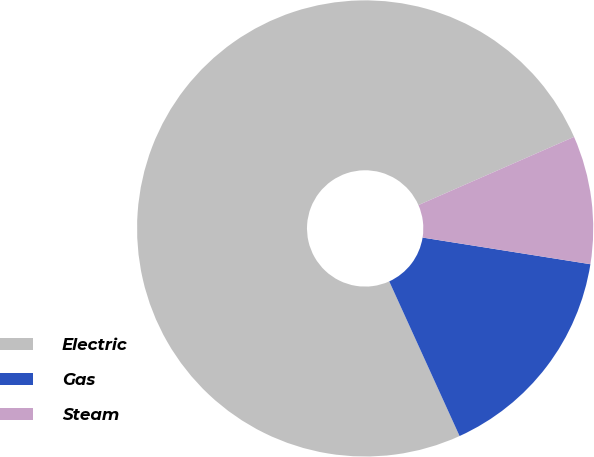<chart> <loc_0><loc_0><loc_500><loc_500><pie_chart><fcel>Electric<fcel>Gas<fcel>Steam<nl><fcel>75.22%<fcel>15.7%<fcel>9.08%<nl></chart> 